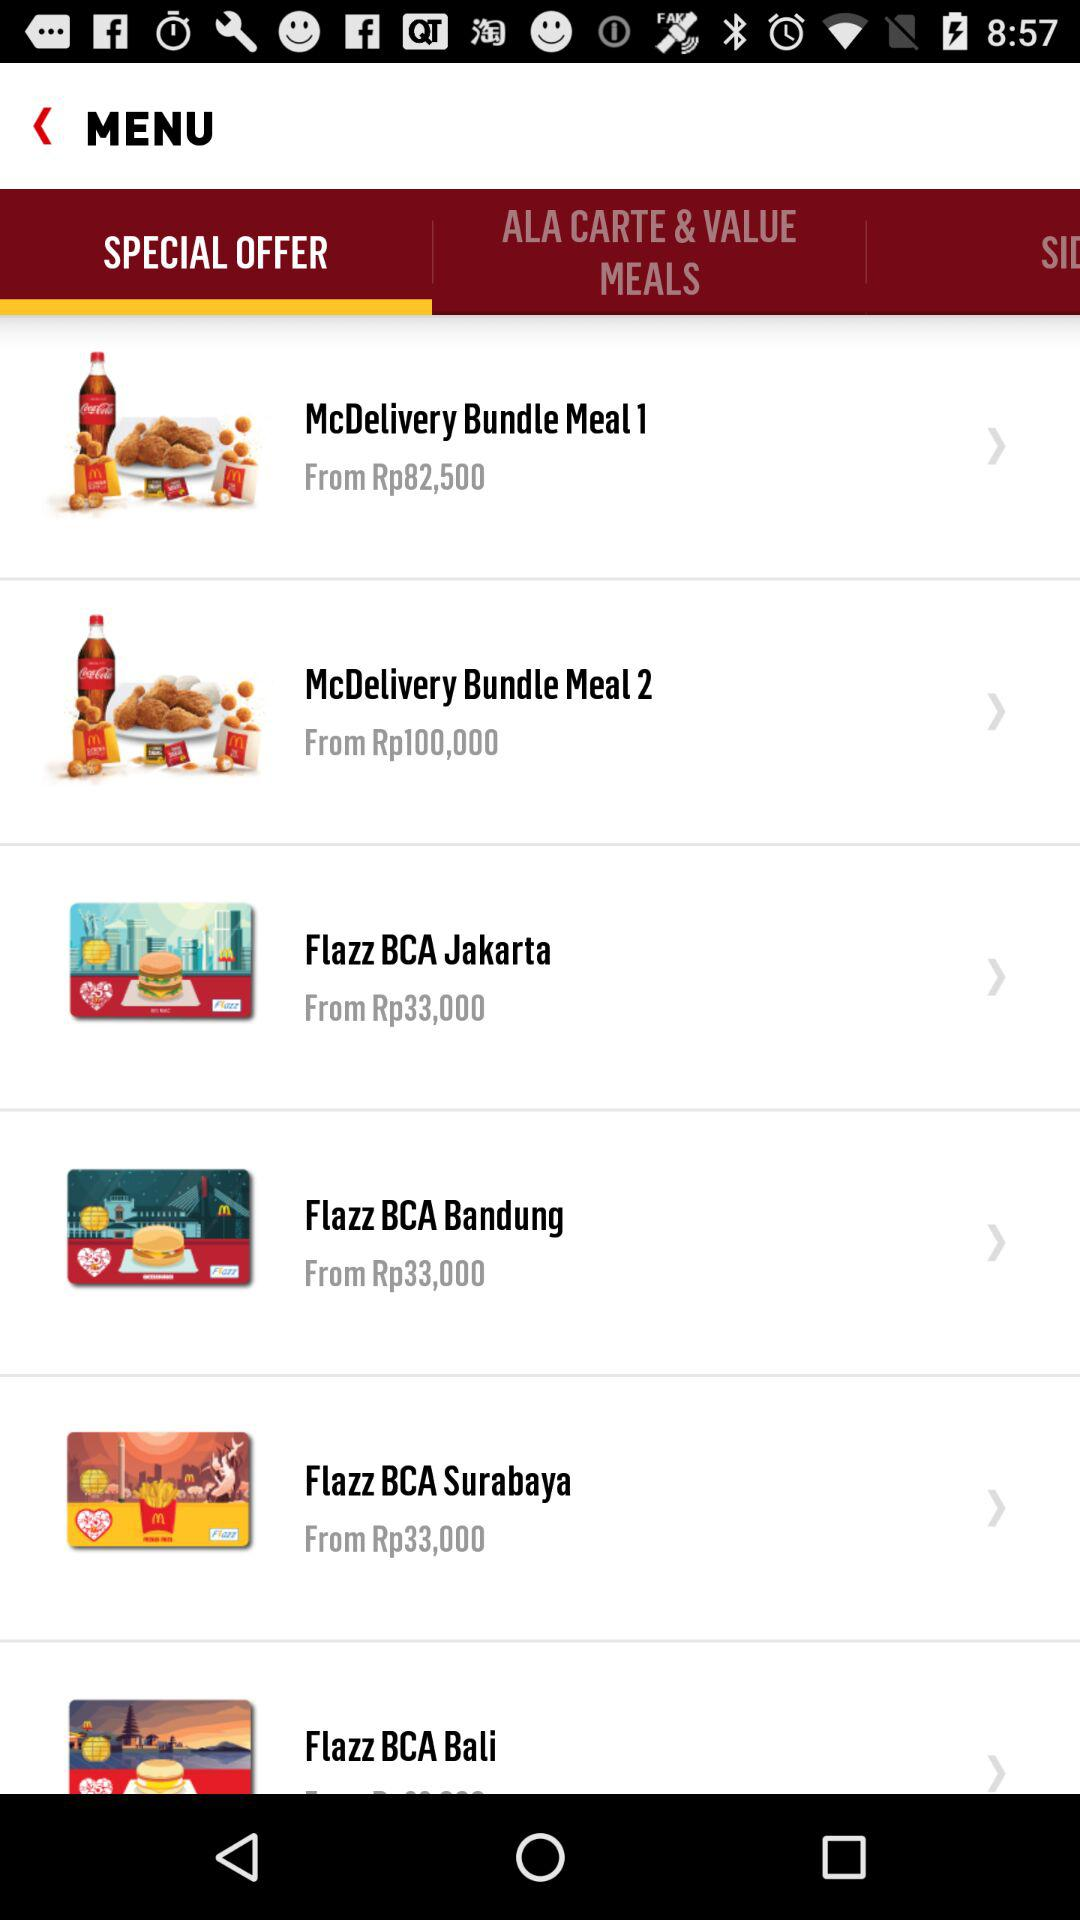How many Flazz BCA options are there?
Answer the question using a single word or phrase. 4 